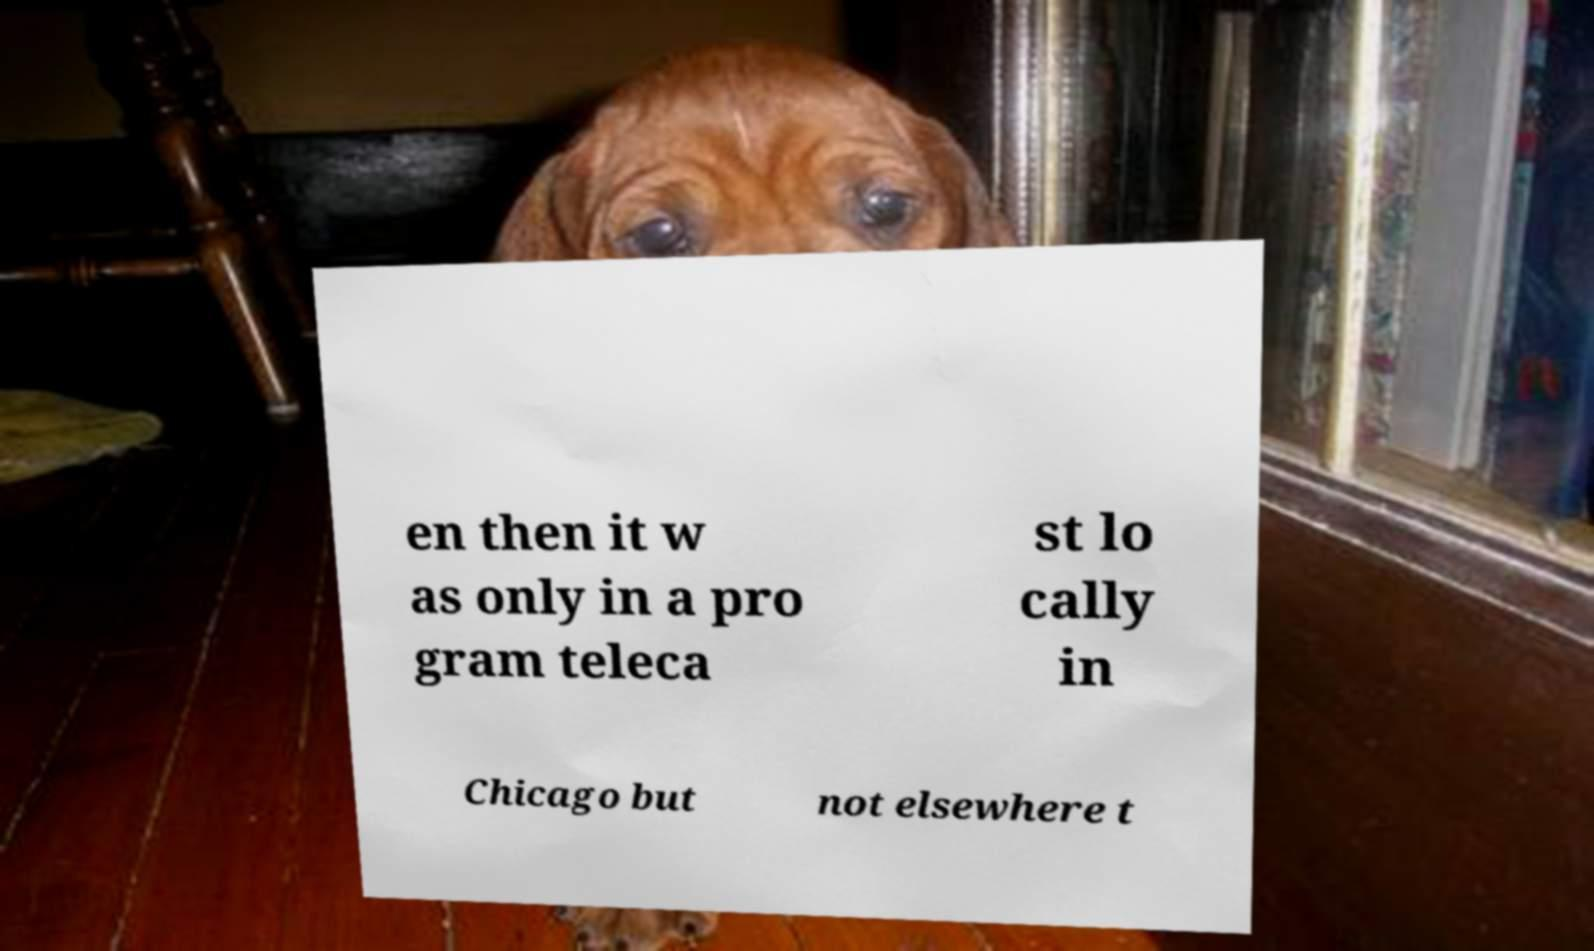What messages or text are displayed in this image? I need them in a readable, typed format. en then it w as only in a pro gram teleca st lo cally in Chicago but not elsewhere t 